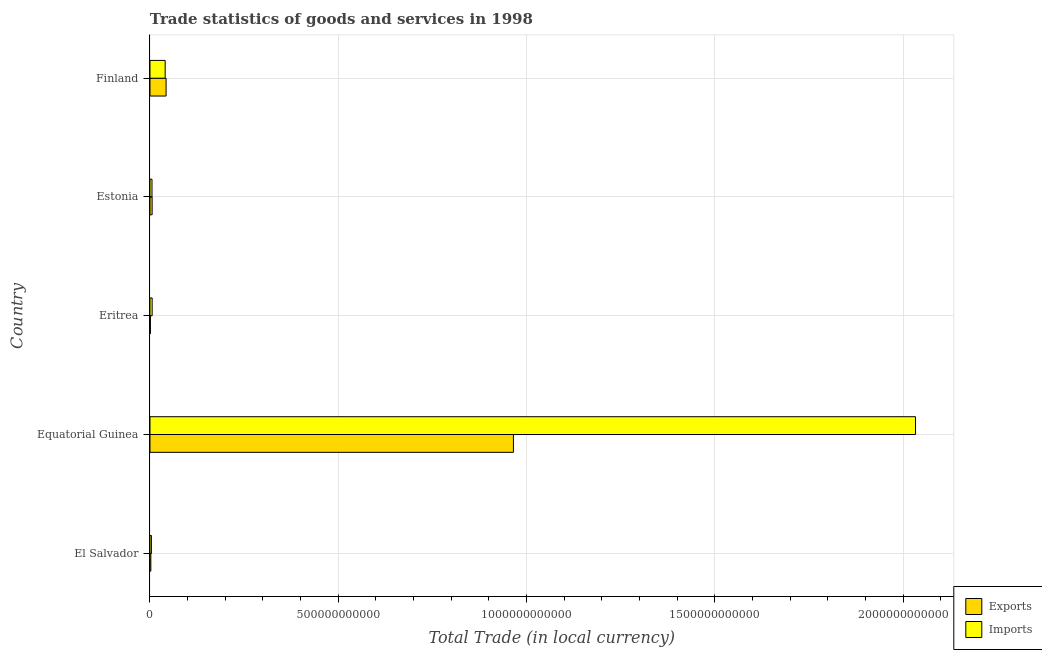Are the number of bars per tick equal to the number of legend labels?
Offer a very short reply. Yes. How many bars are there on the 2nd tick from the top?
Offer a very short reply. 2. How many bars are there on the 5th tick from the bottom?
Offer a terse response. 2. What is the label of the 3rd group of bars from the top?
Your answer should be compact. Eritrea. In how many cases, is the number of bars for a given country not equal to the number of legend labels?
Offer a very short reply. 0. What is the export of goods and services in Finland?
Your response must be concise. 4.28e+1. Across all countries, what is the maximum imports of goods and services?
Your answer should be very brief. 2.03e+12. Across all countries, what is the minimum imports of goods and services?
Keep it short and to the point. 3.76e+09. In which country was the imports of goods and services maximum?
Offer a very short reply. Equatorial Guinea. In which country was the imports of goods and services minimum?
Provide a succinct answer. El Salvador. What is the total export of goods and services in the graph?
Give a very brief answer. 1.02e+12. What is the difference between the export of goods and services in El Salvador and that in Equatorial Guinea?
Provide a short and direct response. -9.63e+11. What is the difference between the imports of goods and services in Estonia and the export of goods and services in Finland?
Give a very brief answer. -3.74e+1. What is the average export of goods and services per country?
Make the answer very short. 2.03e+11. What is the difference between the imports of goods and services and export of goods and services in Finland?
Ensure brevity in your answer.  -2.44e+09. In how many countries, is the export of goods and services greater than 300000000000 LCU?
Provide a succinct answer. 1. What is the ratio of the imports of goods and services in El Salvador to that in Estonia?
Your response must be concise. 0.7. Is the imports of goods and services in Equatorial Guinea less than that in Eritrea?
Ensure brevity in your answer.  No. Is the difference between the export of goods and services in Eritrea and Estonia greater than the difference between the imports of goods and services in Eritrea and Estonia?
Give a very brief answer. No. What is the difference between the highest and the second highest imports of goods and services?
Your response must be concise. 1.99e+12. What is the difference between the highest and the lowest export of goods and services?
Provide a succinct answer. 9.64e+11. Is the sum of the imports of goods and services in El Salvador and Estonia greater than the maximum export of goods and services across all countries?
Keep it short and to the point. No. What does the 2nd bar from the top in Estonia represents?
Ensure brevity in your answer.  Exports. What does the 2nd bar from the bottom in Estonia represents?
Offer a very short reply. Imports. What is the difference between two consecutive major ticks on the X-axis?
Your response must be concise. 5.00e+11. How many legend labels are there?
Provide a succinct answer. 2. How are the legend labels stacked?
Offer a terse response. Vertical. What is the title of the graph?
Provide a succinct answer. Trade statistics of goods and services in 1998. Does "Under-5(female)" appear as one of the legend labels in the graph?
Keep it short and to the point. No. What is the label or title of the X-axis?
Offer a terse response. Total Trade (in local currency). What is the Total Trade (in local currency) of Exports in El Salvador?
Provide a succinct answer. 2.28e+09. What is the Total Trade (in local currency) in Imports in El Salvador?
Provide a short and direct response. 3.76e+09. What is the Total Trade (in local currency) of Exports in Equatorial Guinea?
Keep it short and to the point. 9.65e+11. What is the Total Trade (in local currency) in Imports in Equatorial Guinea?
Provide a succinct answer. 2.03e+12. What is the Total Trade (in local currency) of Exports in Eritrea?
Offer a terse response. 1.07e+09. What is the Total Trade (in local currency) of Imports in Eritrea?
Give a very brief answer. 5.74e+09. What is the Total Trade (in local currency) of Exports in Estonia?
Your answer should be compact. 5.67e+09. What is the Total Trade (in local currency) in Imports in Estonia?
Your answer should be compact. 5.35e+09. What is the Total Trade (in local currency) in Exports in Finland?
Offer a terse response. 4.28e+1. What is the Total Trade (in local currency) of Imports in Finland?
Provide a short and direct response. 4.03e+1. Across all countries, what is the maximum Total Trade (in local currency) of Exports?
Provide a short and direct response. 9.65e+11. Across all countries, what is the maximum Total Trade (in local currency) of Imports?
Your response must be concise. 2.03e+12. Across all countries, what is the minimum Total Trade (in local currency) in Exports?
Keep it short and to the point. 1.07e+09. Across all countries, what is the minimum Total Trade (in local currency) of Imports?
Offer a very short reply. 3.76e+09. What is the total Total Trade (in local currency) of Exports in the graph?
Give a very brief answer. 1.02e+12. What is the total Total Trade (in local currency) in Imports in the graph?
Your answer should be very brief. 2.09e+12. What is the difference between the Total Trade (in local currency) in Exports in El Salvador and that in Equatorial Guinea?
Offer a terse response. -9.63e+11. What is the difference between the Total Trade (in local currency) of Imports in El Salvador and that in Equatorial Guinea?
Offer a very short reply. -2.03e+12. What is the difference between the Total Trade (in local currency) in Exports in El Salvador and that in Eritrea?
Offer a terse response. 1.21e+09. What is the difference between the Total Trade (in local currency) of Imports in El Salvador and that in Eritrea?
Your answer should be very brief. -1.99e+09. What is the difference between the Total Trade (in local currency) in Exports in El Salvador and that in Estonia?
Offer a very short reply. -3.39e+09. What is the difference between the Total Trade (in local currency) in Imports in El Salvador and that in Estonia?
Provide a short and direct response. -1.60e+09. What is the difference between the Total Trade (in local currency) of Exports in El Salvador and that in Finland?
Make the answer very short. -4.05e+1. What is the difference between the Total Trade (in local currency) in Imports in El Salvador and that in Finland?
Ensure brevity in your answer.  -3.66e+1. What is the difference between the Total Trade (in local currency) of Exports in Equatorial Guinea and that in Eritrea?
Your answer should be very brief. 9.64e+11. What is the difference between the Total Trade (in local currency) of Imports in Equatorial Guinea and that in Eritrea?
Your answer should be compact. 2.03e+12. What is the difference between the Total Trade (in local currency) of Exports in Equatorial Guinea and that in Estonia?
Keep it short and to the point. 9.59e+11. What is the difference between the Total Trade (in local currency) of Imports in Equatorial Guinea and that in Estonia?
Give a very brief answer. 2.03e+12. What is the difference between the Total Trade (in local currency) in Exports in Equatorial Guinea and that in Finland?
Your answer should be very brief. 9.22e+11. What is the difference between the Total Trade (in local currency) in Imports in Equatorial Guinea and that in Finland?
Provide a short and direct response. 1.99e+12. What is the difference between the Total Trade (in local currency) in Exports in Eritrea and that in Estonia?
Your response must be concise. -4.60e+09. What is the difference between the Total Trade (in local currency) of Imports in Eritrea and that in Estonia?
Your answer should be compact. 3.87e+08. What is the difference between the Total Trade (in local currency) in Exports in Eritrea and that in Finland?
Provide a succinct answer. -4.17e+1. What is the difference between the Total Trade (in local currency) in Imports in Eritrea and that in Finland?
Offer a very short reply. -3.46e+1. What is the difference between the Total Trade (in local currency) in Exports in Estonia and that in Finland?
Your response must be concise. -3.71e+1. What is the difference between the Total Trade (in local currency) in Imports in Estonia and that in Finland?
Your response must be concise. -3.50e+1. What is the difference between the Total Trade (in local currency) of Exports in El Salvador and the Total Trade (in local currency) of Imports in Equatorial Guinea?
Make the answer very short. -2.03e+12. What is the difference between the Total Trade (in local currency) in Exports in El Salvador and the Total Trade (in local currency) in Imports in Eritrea?
Your answer should be very brief. -3.46e+09. What is the difference between the Total Trade (in local currency) in Exports in El Salvador and the Total Trade (in local currency) in Imports in Estonia?
Your answer should be compact. -3.07e+09. What is the difference between the Total Trade (in local currency) of Exports in El Salvador and the Total Trade (in local currency) of Imports in Finland?
Your response must be concise. -3.80e+1. What is the difference between the Total Trade (in local currency) in Exports in Equatorial Guinea and the Total Trade (in local currency) in Imports in Eritrea?
Offer a terse response. 9.59e+11. What is the difference between the Total Trade (in local currency) in Exports in Equatorial Guinea and the Total Trade (in local currency) in Imports in Estonia?
Make the answer very short. 9.60e+11. What is the difference between the Total Trade (in local currency) of Exports in Equatorial Guinea and the Total Trade (in local currency) of Imports in Finland?
Offer a terse response. 9.25e+11. What is the difference between the Total Trade (in local currency) in Exports in Eritrea and the Total Trade (in local currency) in Imports in Estonia?
Offer a terse response. -4.28e+09. What is the difference between the Total Trade (in local currency) in Exports in Eritrea and the Total Trade (in local currency) in Imports in Finland?
Keep it short and to the point. -3.93e+1. What is the difference between the Total Trade (in local currency) of Exports in Estonia and the Total Trade (in local currency) of Imports in Finland?
Your answer should be very brief. -3.47e+1. What is the average Total Trade (in local currency) of Exports per country?
Your answer should be compact. 2.03e+11. What is the average Total Trade (in local currency) of Imports per country?
Give a very brief answer. 4.18e+11. What is the difference between the Total Trade (in local currency) of Exports and Total Trade (in local currency) of Imports in El Salvador?
Provide a short and direct response. -1.47e+09. What is the difference between the Total Trade (in local currency) of Exports and Total Trade (in local currency) of Imports in Equatorial Guinea?
Make the answer very short. -1.07e+12. What is the difference between the Total Trade (in local currency) of Exports and Total Trade (in local currency) of Imports in Eritrea?
Provide a succinct answer. -4.67e+09. What is the difference between the Total Trade (in local currency) in Exports and Total Trade (in local currency) in Imports in Estonia?
Offer a very short reply. 3.16e+08. What is the difference between the Total Trade (in local currency) in Exports and Total Trade (in local currency) in Imports in Finland?
Your response must be concise. 2.44e+09. What is the ratio of the Total Trade (in local currency) of Exports in El Salvador to that in Equatorial Guinea?
Your response must be concise. 0. What is the ratio of the Total Trade (in local currency) in Imports in El Salvador to that in Equatorial Guinea?
Offer a very short reply. 0. What is the ratio of the Total Trade (in local currency) in Exports in El Salvador to that in Eritrea?
Provide a short and direct response. 2.13. What is the ratio of the Total Trade (in local currency) of Imports in El Salvador to that in Eritrea?
Ensure brevity in your answer.  0.65. What is the ratio of the Total Trade (in local currency) in Exports in El Salvador to that in Estonia?
Provide a succinct answer. 0.4. What is the ratio of the Total Trade (in local currency) of Imports in El Salvador to that in Estonia?
Provide a succinct answer. 0.7. What is the ratio of the Total Trade (in local currency) of Exports in El Salvador to that in Finland?
Give a very brief answer. 0.05. What is the ratio of the Total Trade (in local currency) of Imports in El Salvador to that in Finland?
Your answer should be very brief. 0.09. What is the ratio of the Total Trade (in local currency) in Exports in Equatorial Guinea to that in Eritrea?
Your answer should be very brief. 899.88. What is the ratio of the Total Trade (in local currency) of Imports in Equatorial Guinea to that in Eritrea?
Your response must be concise. 354.06. What is the ratio of the Total Trade (in local currency) of Exports in Equatorial Guinea to that in Estonia?
Your response must be concise. 170.21. What is the ratio of the Total Trade (in local currency) of Imports in Equatorial Guinea to that in Estonia?
Offer a very short reply. 379.68. What is the ratio of the Total Trade (in local currency) of Exports in Equatorial Guinea to that in Finland?
Provide a short and direct response. 22.57. What is the ratio of the Total Trade (in local currency) of Imports in Equatorial Guinea to that in Finland?
Give a very brief answer. 50.41. What is the ratio of the Total Trade (in local currency) of Exports in Eritrea to that in Estonia?
Ensure brevity in your answer.  0.19. What is the ratio of the Total Trade (in local currency) in Imports in Eritrea to that in Estonia?
Ensure brevity in your answer.  1.07. What is the ratio of the Total Trade (in local currency) of Exports in Eritrea to that in Finland?
Keep it short and to the point. 0.03. What is the ratio of the Total Trade (in local currency) of Imports in Eritrea to that in Finland?
Your answer should be compact. 0.14. What is the ratio of the Total Trade (in local currency) in Exports in Estonia to that in Finland?
Your response must be concise. 0.13. What is the ratio of the Total Trade (in local currency) of Imports in Estonia to that in Finland?
Offer a terse response. 0.13. What is the difference between the highest and the second highest Total Trade (in local currency) of Exports?
Your answer should be compact. 9.22e+11. What is the difference between the highest and the second highest Total Trade (in local currency) in Imports?
Your answer should be compact. 1.99e+12. What is the difference between the highest and the lowest Total Trade (in local currency) in Exports?
Ensure brevity in your answer.  9.64e+11. What is the difference between the highest and the lowest Total Trade (in local currency) in Imports?
Ensure brevity in your answer.  2.03e+12. 